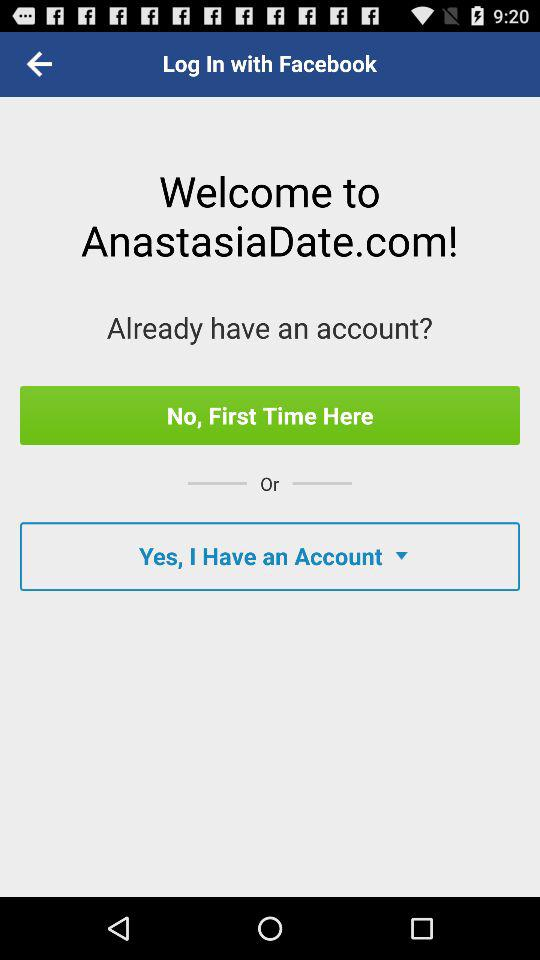Through what application can we login? You can login through "Facebook". 